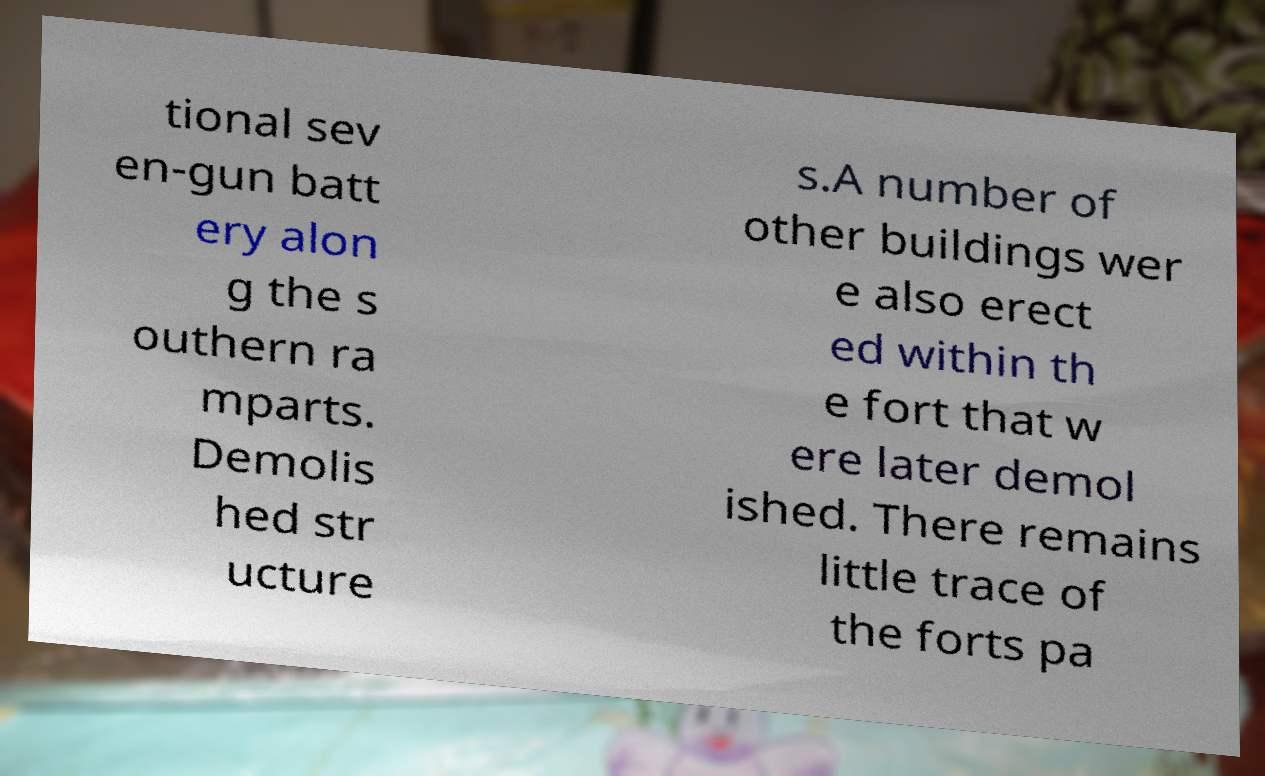Could you extract and type out the text from this image? tional sev en-gun batt ery alon g the s outhern ra mparts. Demolis hed str ucture s.A number of other buildings wer e also erect ed within th e fort that w ere later demol ished. There remains little trace of the forts pa 